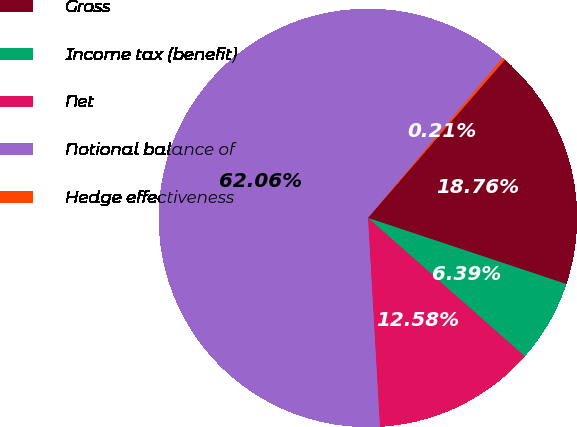<chart> <loc_0><loc_0><loc_500><loc_500><pie_chart><fcel>Gross<fcel>Income tax (benefit)<fcel>Net<fcel>Notional balance of<fcel>Hedge effectiveness<nl><fcel>18.76%<fcel>6.39%<fcel>12.58%<fcel>62.06%<fcel>0.21%<nl></chart> 